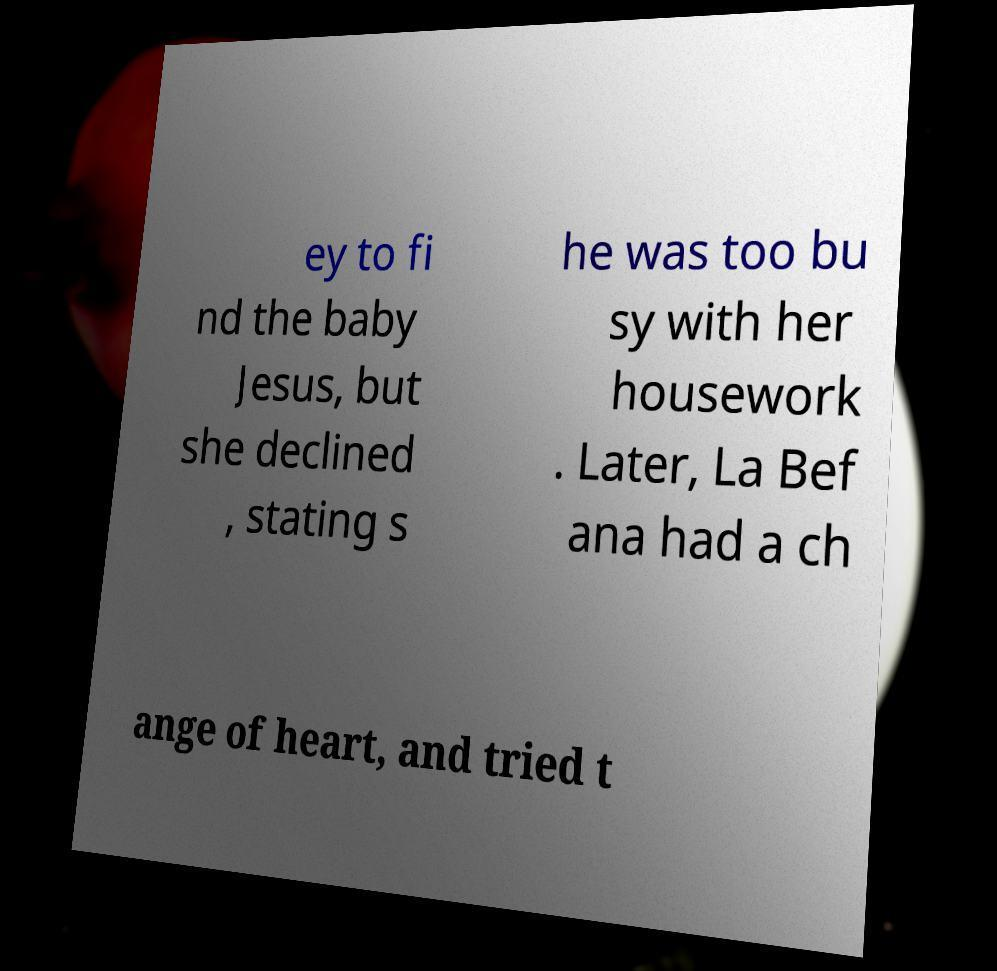What messages or text are displayed in this image? I need them in a readable, typed format. ey to fi nd the baby Jesus, but she declined , stating s he was too bu sy with her housework . Later, La Bef ana had a ch ange of heart, and tried t 